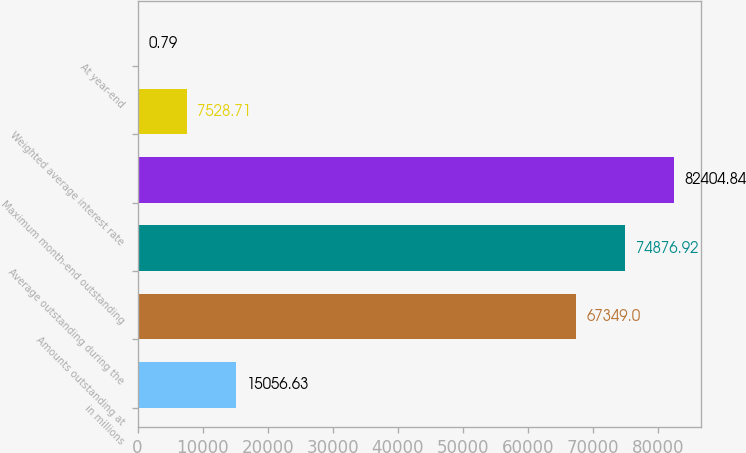<chart> <loc_0><loc_0><loc_500><loc_500><bar_chart><fcel>in millions<fcel>Amounts outstanding at<fcel>Average outstanding during the<fcel>Maximum month-end outstanding<fcel>Weighted average interest rate<fcel>At year-end<nl><fcel>15056.6<fcel>67349<fcel>74876.9<fcel>82404.8<fcel>7528.71<fcel>0.79<nl></chart> 